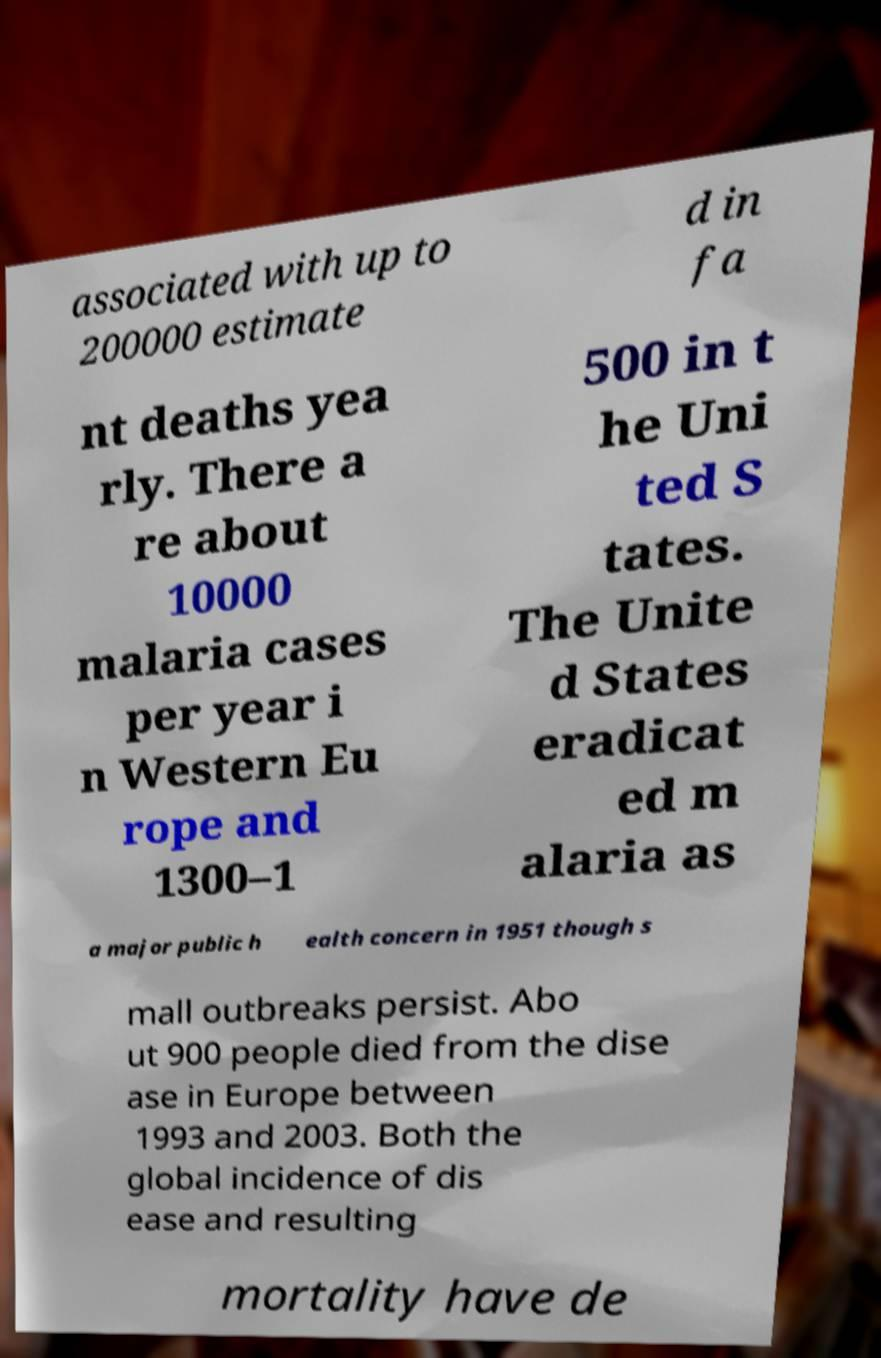What messages or text are displayed in this image? I need them in a readable, typed format. associated with up to 200000 estimate d in fa nt deaths yea rly. There a re about 10000 malaria cases per year i n Western Eu rope and 1300–1 500 in t he Uni ted S tates. The Unite d States eradicat ed m alaria as a major public h ealth concern in 1951 though s mall outbreaks persist. Abo ut 900 people died from the dise ase in Europe between 1993 and 2003. Both the global incidence of dis ease and resulting mortality have de 